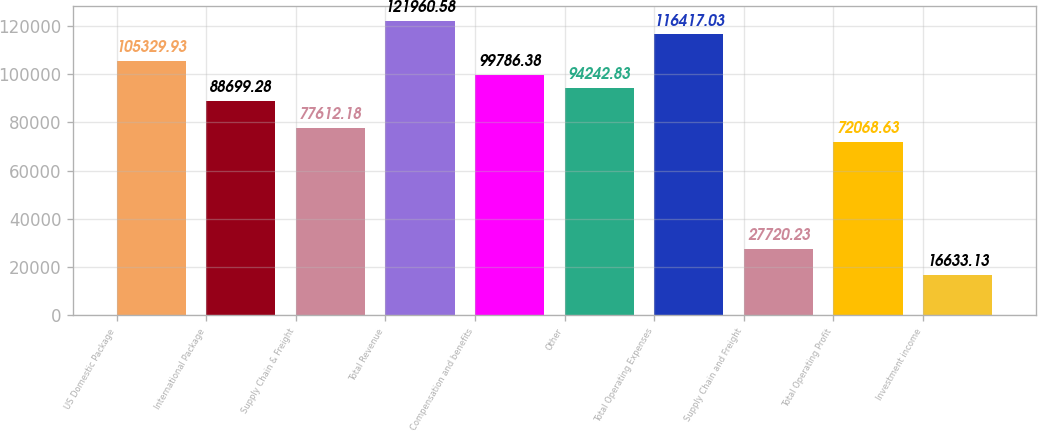Convert chart. <chart><loc_0><loc_0><loc_500><loc_500><bar_chart><fcel>US Domestic Package<fcel>International Package<fcel>Supply Chain & Freight<fcel>Total Revenue<fcel>Compensation and benefits<fcel>Other<fcel>Total Operating Expenses<fcel>Supply Chain and Freight<fcel>Total Operating Profit<fcel>Investment income<nl><fcel>105330<fcel>88699.3<fcel>77612.2<fcel>121961<fcel>99786.4<fcel>94242.8<fcel>116417<fcel>27720.2<fcel>72068.6<fcel>16633.1<nl></chart> 